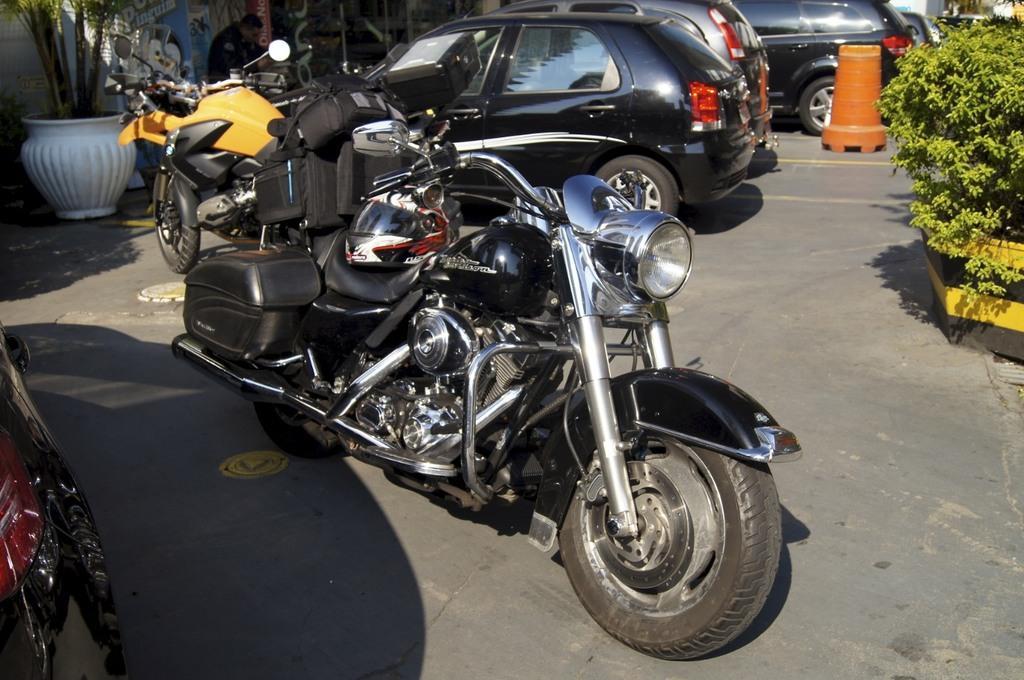Describe this image in one or two sentences. In this picture, we see the bikes and the cars are parked on the road. On the right side, we see the shrubs and the traffic stopper. On the left side, we see the flower pot. Beside that, we see the man is sitting. In the left bottom, we see the tail light of the car. This picture is clicked outside the city. 